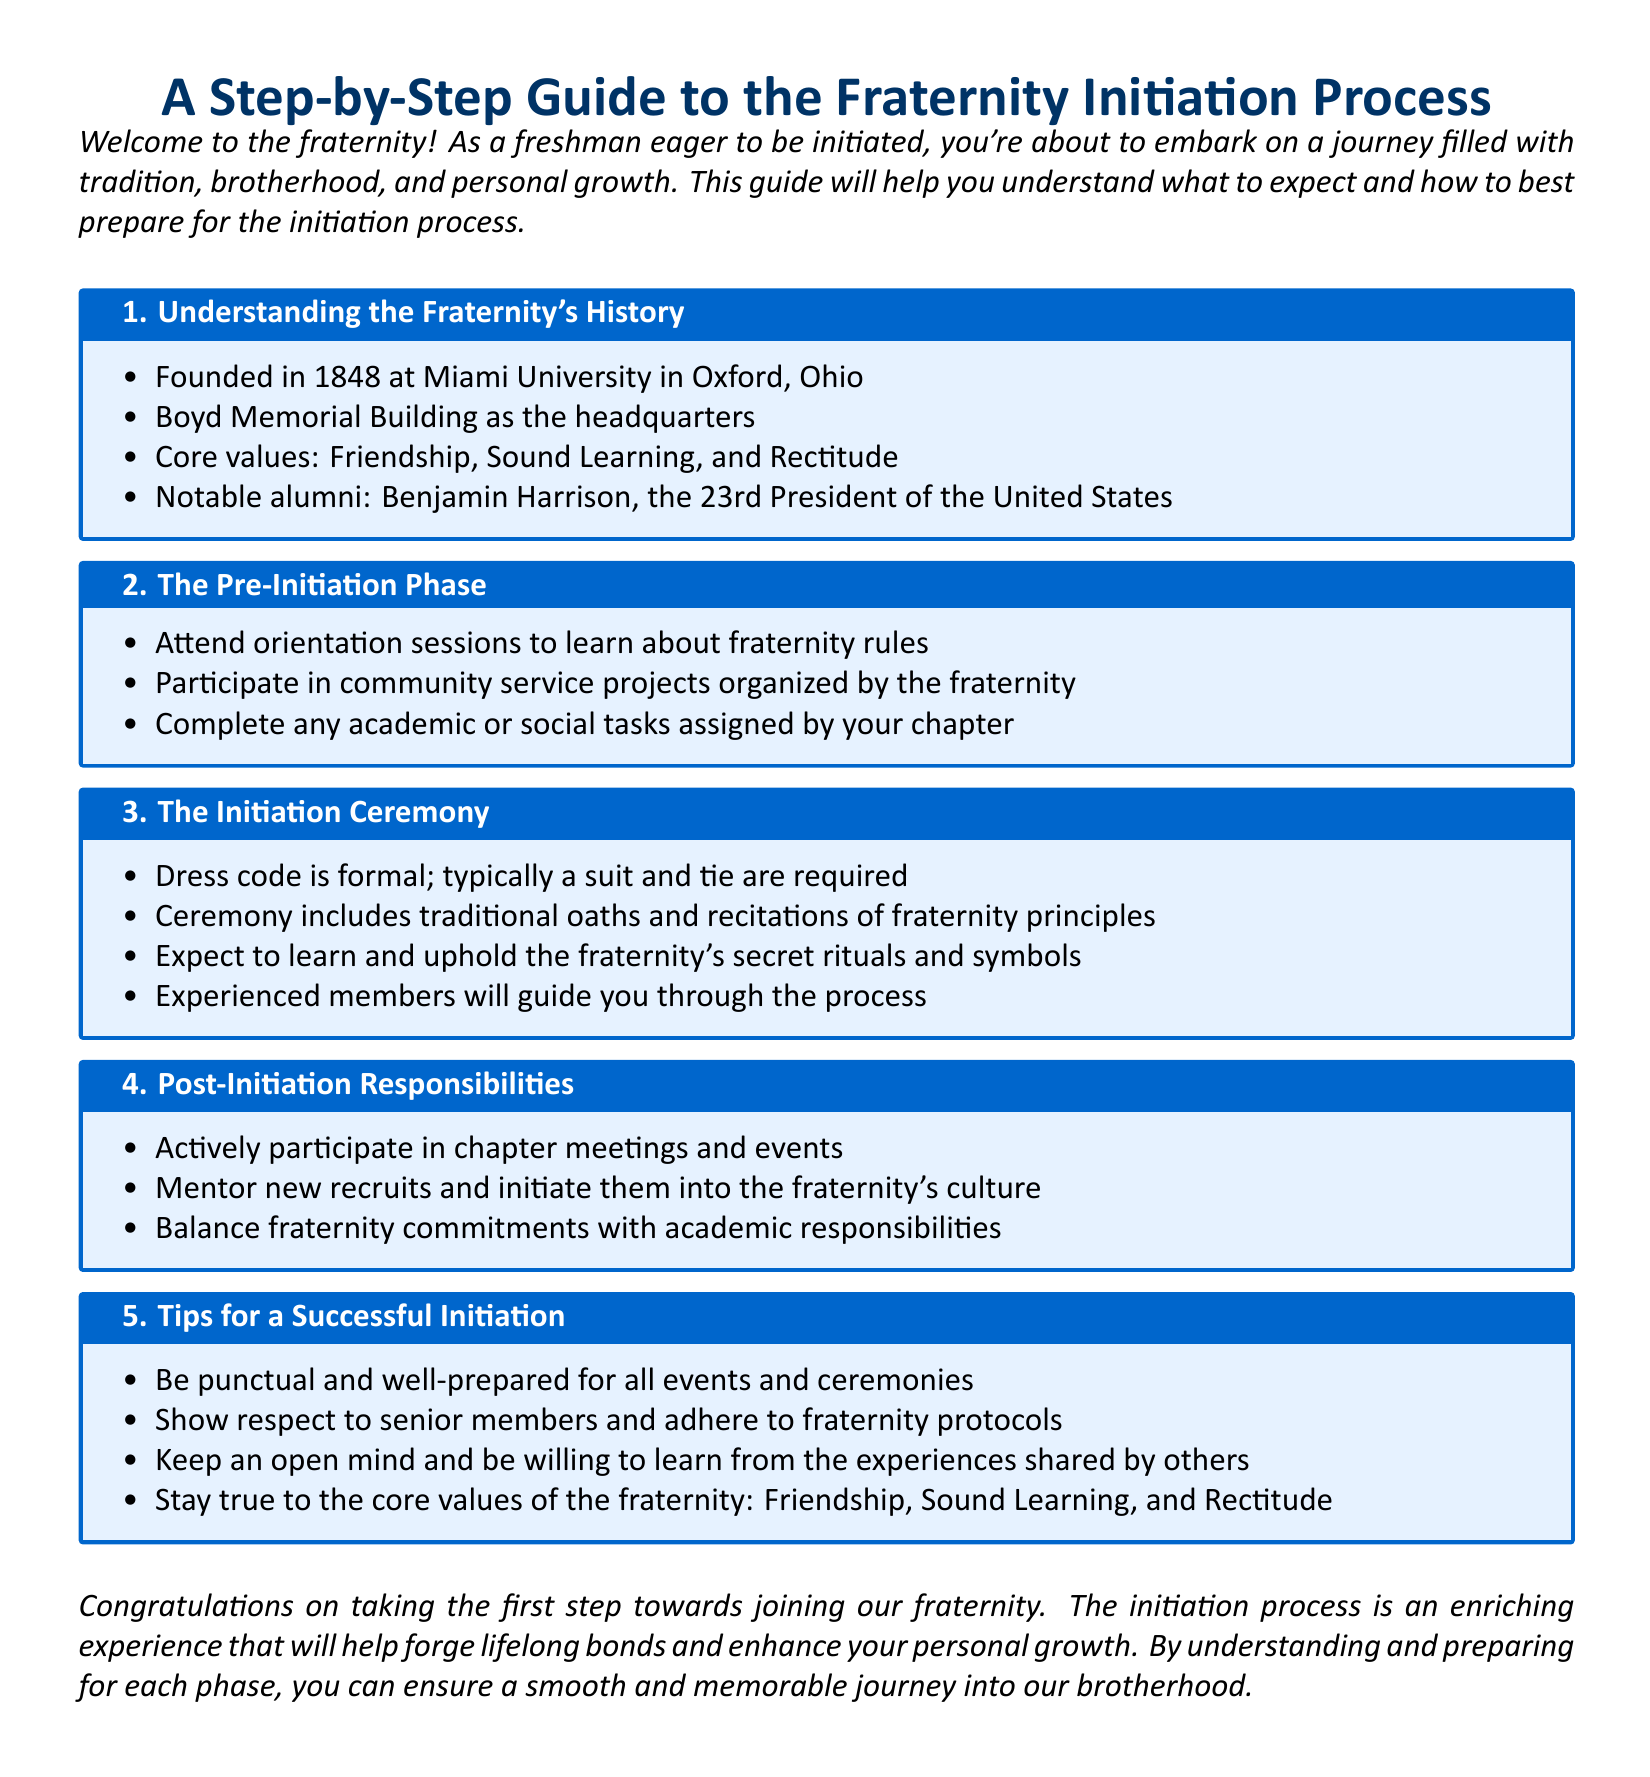What year was the fraternity founded? The founding year of the fraternity is mentioned in the history section of the document.
Answer: 1848 Where is the headquarters of the fraternity located? The document specifies the Boyd Memorial Building as the fraternity's headquarters.
Answer: Boyd Memorial Building What are the core values of the fraternity? The document lists the fraternity's core values in the history section.
Answer: Friendship, Sound Learning, and Rectitude What is required for the dress code during the initiation ceremony? The dress code for the initiation ceremony is outlined in its dedicated section.
Answer: Formal; typically a suit and tie What should new members do after being initiated? Post-initiation responsibilities are described in a specific section of the document.
Answer: Participate in chapter meetings and events Why is community service important in the pre-initiation phase? Reasons for participating in community service can be inferred as part of the fraternity's values and preparation.
Answer: To learn fraternity values Which notable alumni is mentioned in the document? The document references a significant alumnus in the history section.
Answer: Benjamin Harrison What should you keep true to during the initiation process? The tips for a successful initiation advise adherence to certain core values.
Answer: Core values of the fraternity What type of projects should new members participate in during pre-initiation? The document specifies activities for new members in the pre-initiation phase.
Answer: Community service projects 